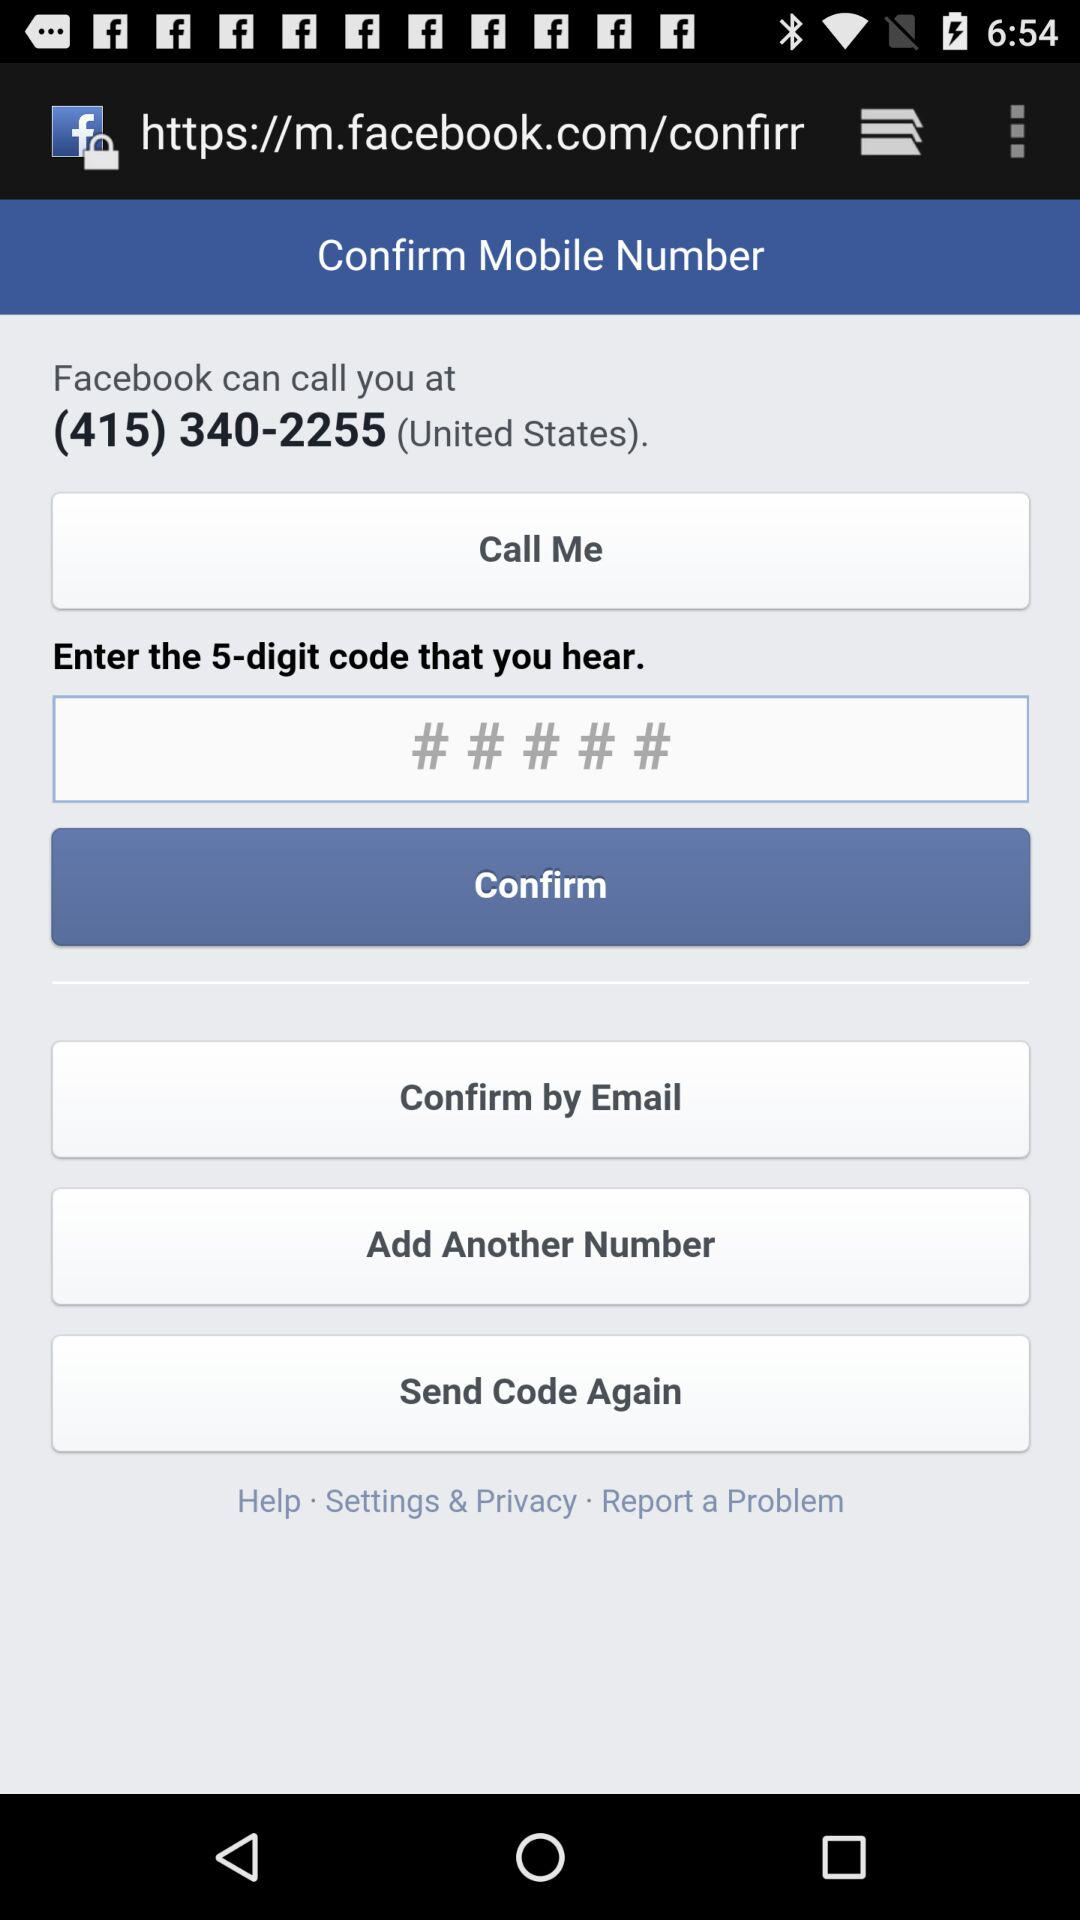Which country is mentioned? The mentioned country is the United States. 